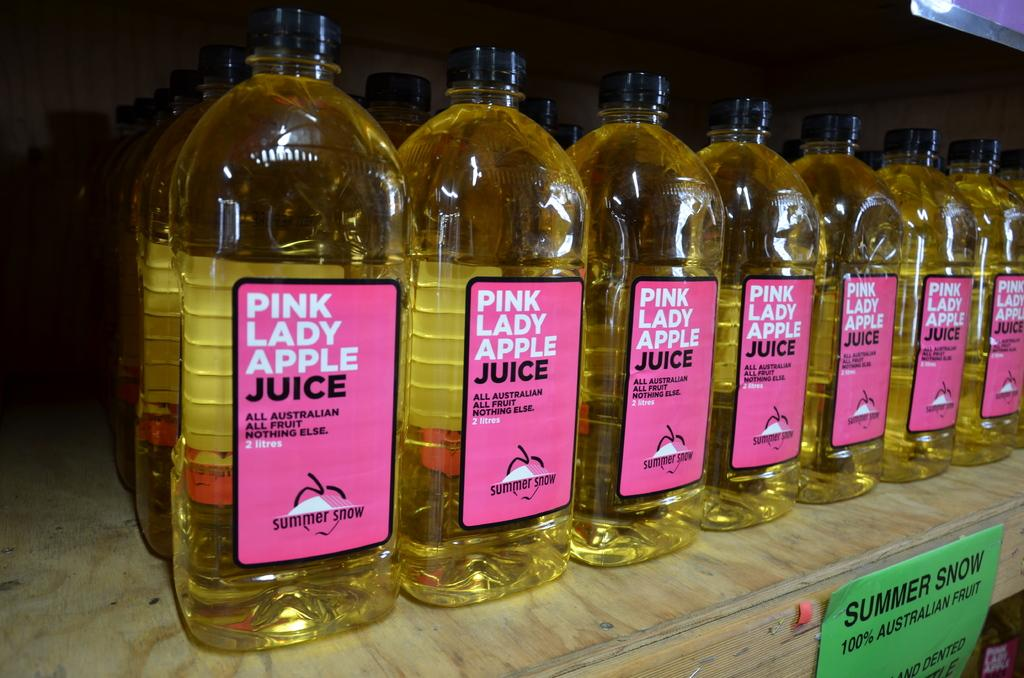What can be seen in the image? There is a bottle in the image. What is inside the bottle? The bottle contains fruit juice. What type of fruit juice is in the bottle? The fruit juice is "Pink Lady Apple Juice." What color is the rose on the bottle in the image? There is no rose present on the bottle in the image. 